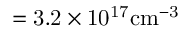Convert formula to latex. <formula><loc_0><loc_0><loc_500><loc_500>= 3 . 2 \times 1 0 ^ { 1 7 } c m ^ { - 3 }</formula> 